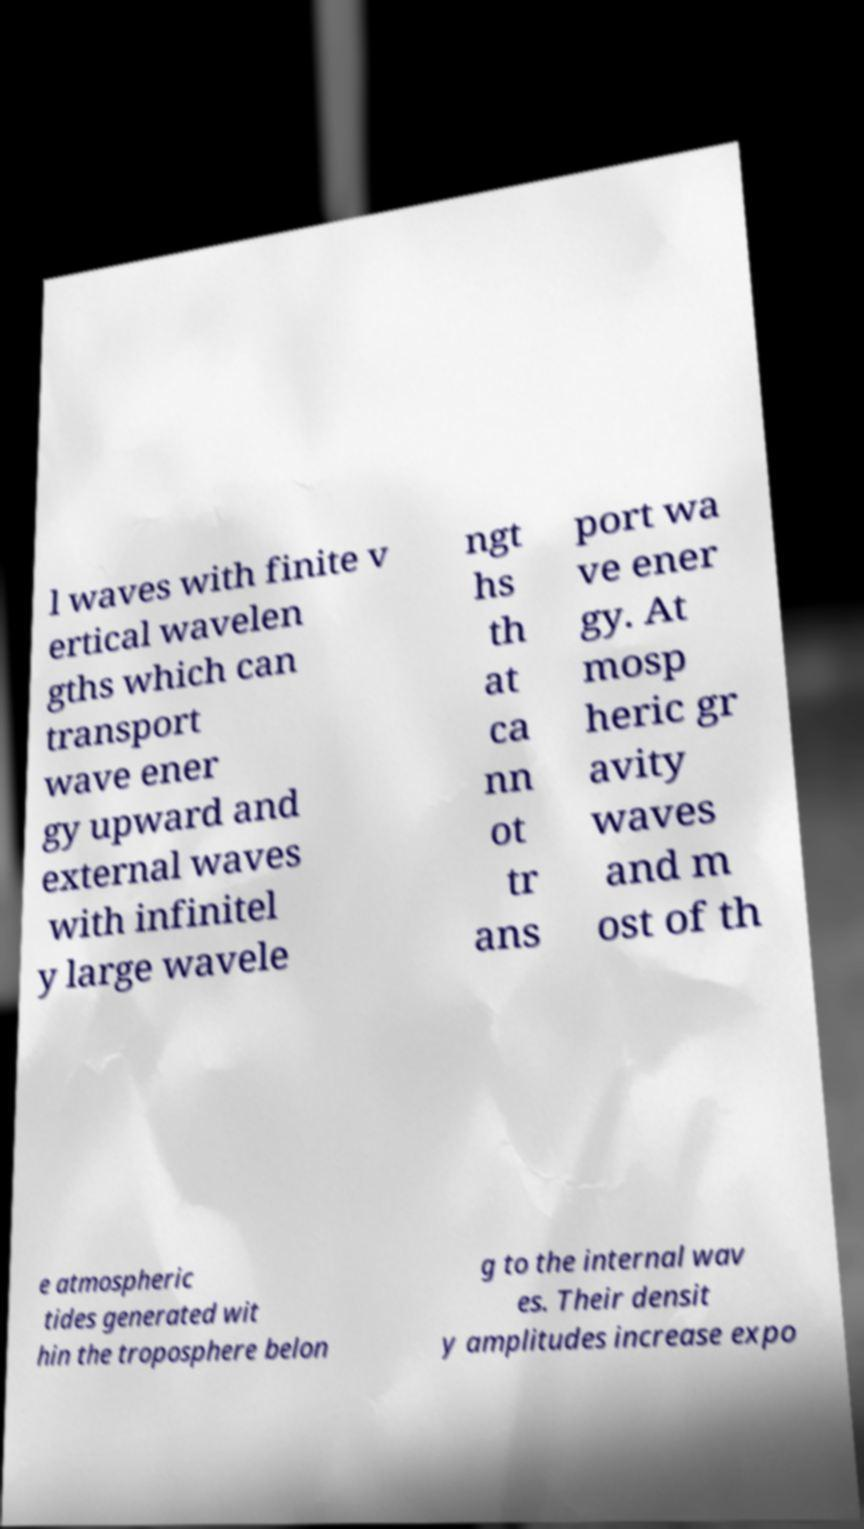Please identify and transcribe the text found in this image. l waves with finite v ertical wavelen gths which can transport wave ener gy upward and external waves with infinitel y large wavele ngt hs th at ca nn ot tr ans port wa ve ener gy. At mosp heric gr avity waves and m ost of th e atmospheric tides generated wit hin the troposphere belon g to the internal wav es. Their densit y amplitudes increase expo 